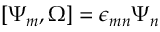<formula> <loc_0><loc_0><loc_500><loc_500>[ \Psi _ { m } , \Omega ] = \epsilon _ { m n } \Psi _ { n }</formula> 